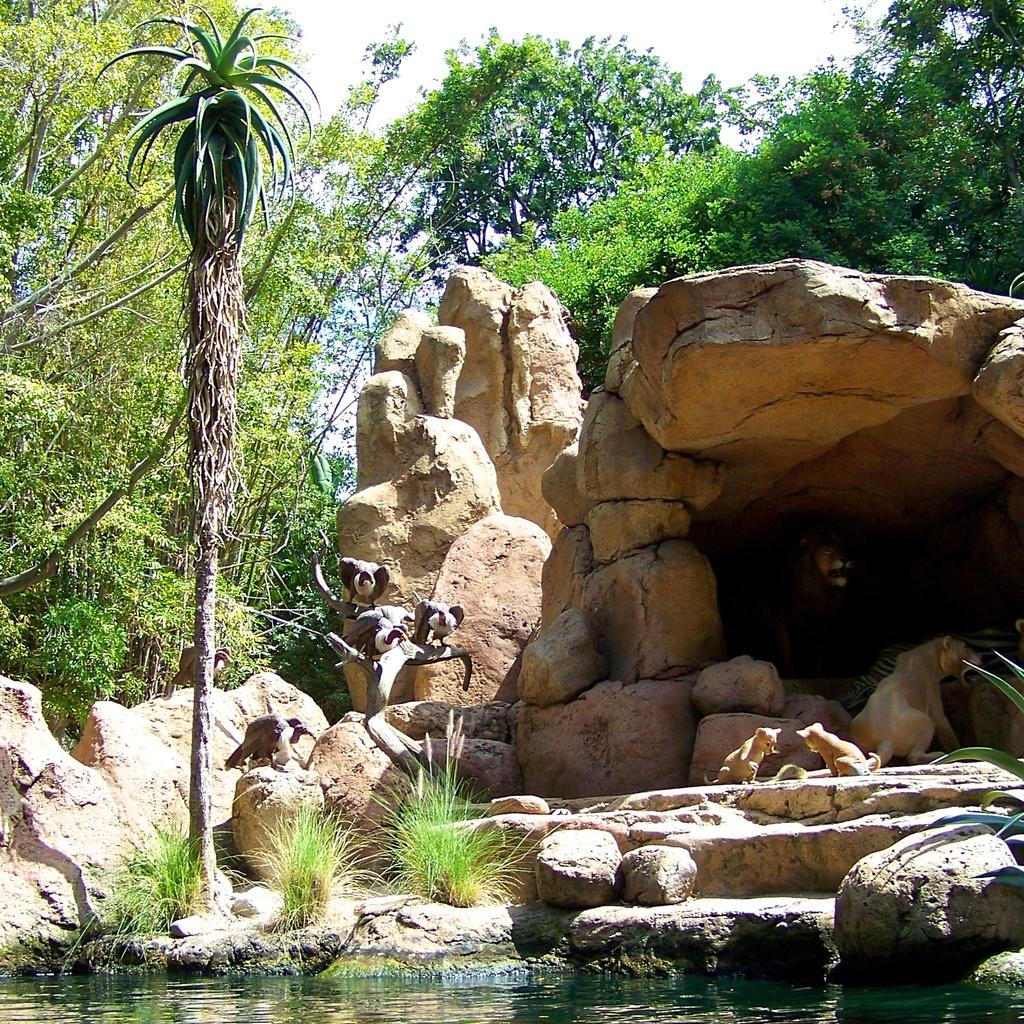What types of living organisms can be seen in the foreground of the image? There are animals in the foreground of the image. What other elements are present in the foreground of the image? There are stones and water in the foreground of the image. What can be seen in the background of the image? There are trees, a den, stones, and the sky visible in the background of the image. What type of plant is being used as a waste disposal in the image? There is no plant being used as a waste disposal in the image. What is the size of the den in the background of the image? The size of the den cannot be determined from the image alone. 